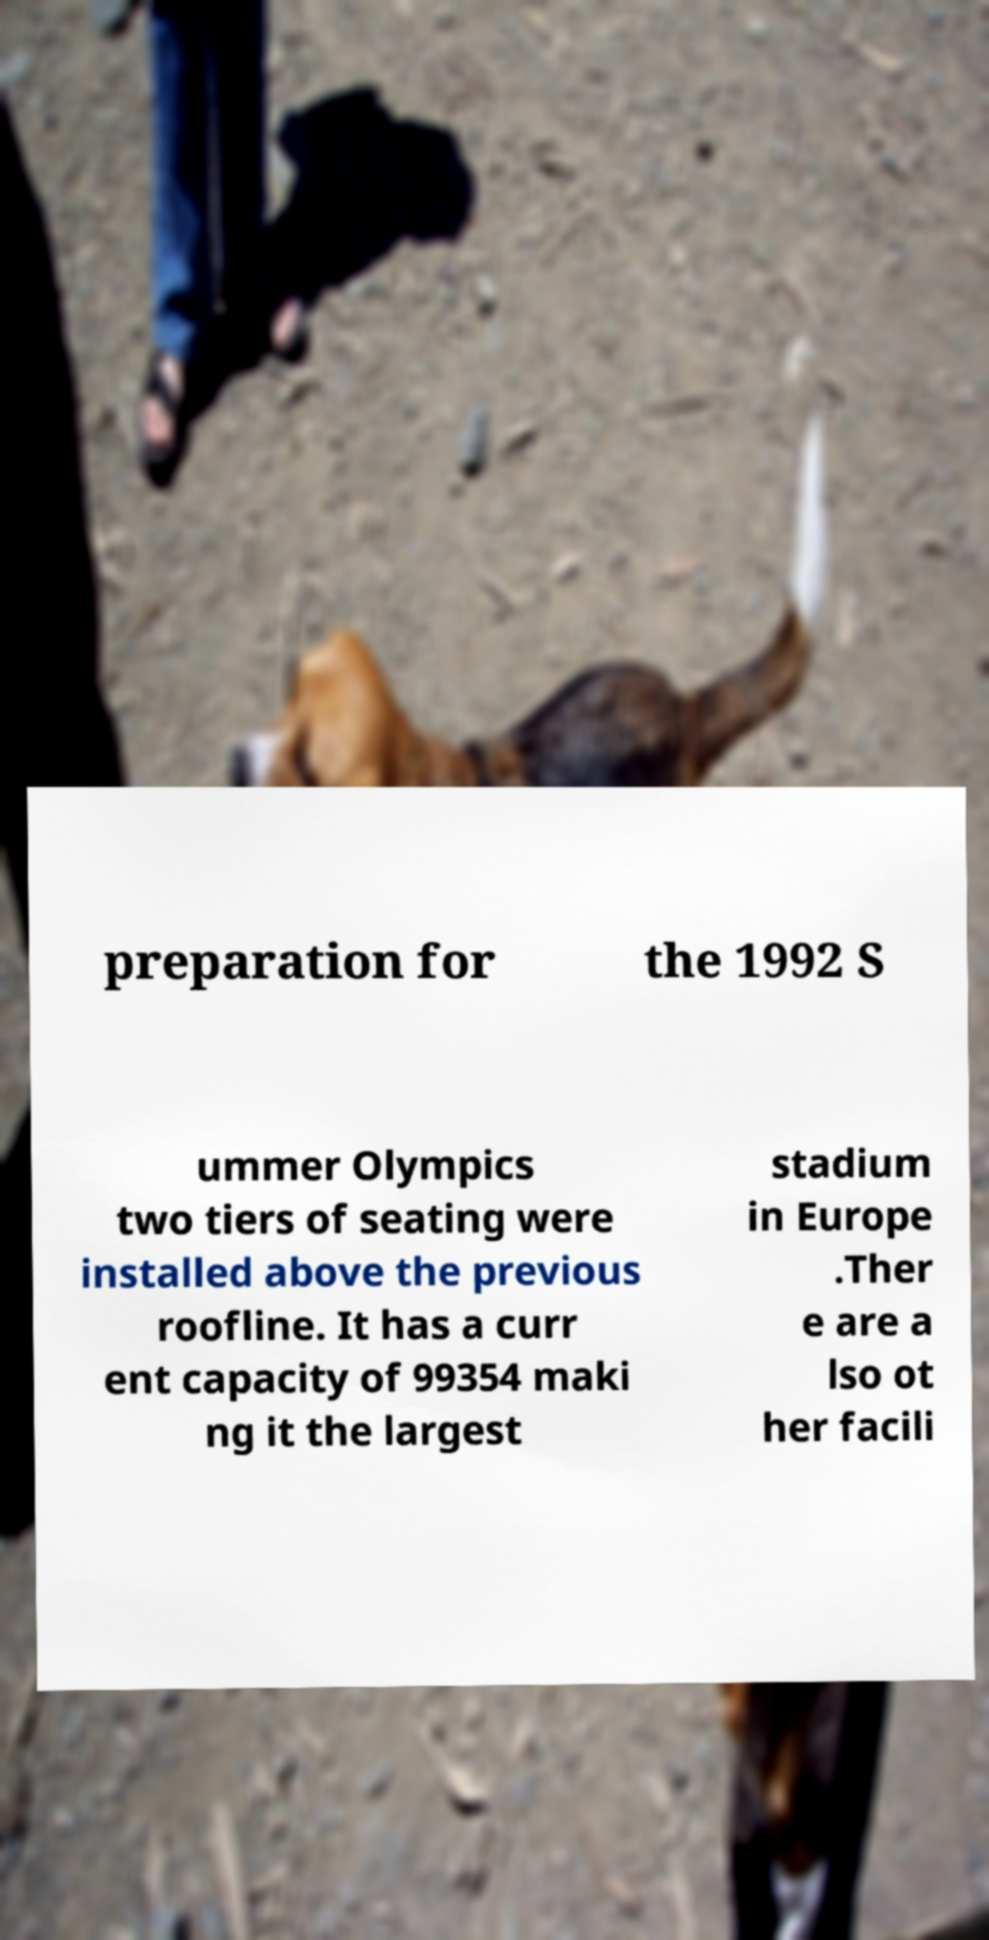Can you accurately transcribe the text from the provided image for me? preparation for the 1992 S ummer Olympics two tiers of seating were installed above the previous roofline. It has a curr ent capacity of 99354 maki ng it the largest stadium in Europe .Ther e are a lso ot her facili 